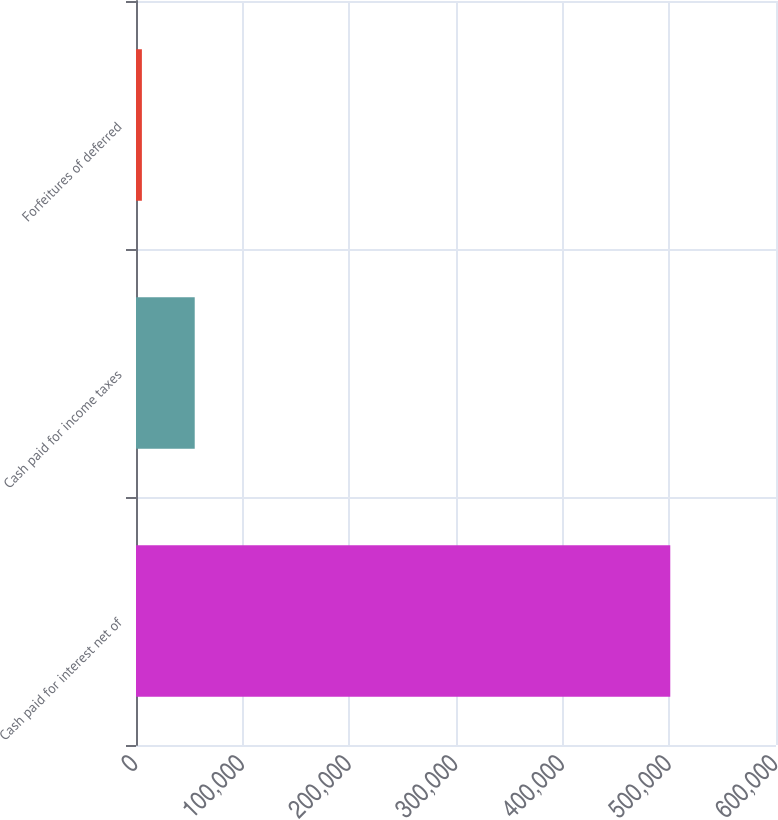Convert chart. <chart><loc_0><loc_0><loc_500><loc_500><bar_chart><fcel>Cash paid for interest net of<fcel>Cash paid for income taxes<fcel>Forfeitures of deferred<nl><fcel>500879<fcel>55055.9<fcel>5520<nl></chart> 